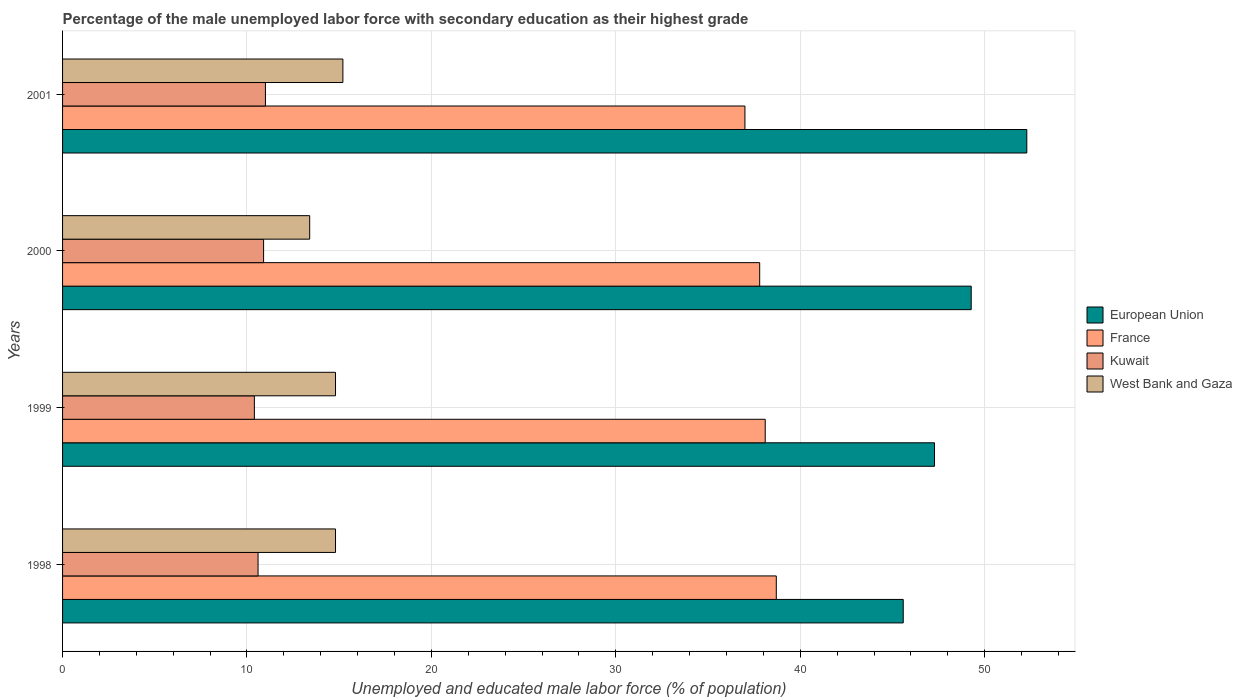How many different coloured bars are there?
Provide a succinct answer. 4. How many groups of bars are there?
Offer a terse response. 4. Are the number of bars per tick equal to the number of legend labels?
Provide a short and direct response. Yes. What is the label of the 3rd group of bars from the top?
Your answer should be very brief. 1999. What is the percentage of the unemployed male labor force with secondary education in West Bank and Gaza in 2001?
Keep it short and to the point. 15.2. Across all years, what is the maximum percentage of the unemployed male labor force with secondary education in Kuwait?
Make the answer very short. 11. Across all years, what is the minimum percentage of the unemployed male labor force with secondary education in European Union?
Provide a short and direct response. 45.58. In which year was the percentage of the unemployed male labor force with secondary education in Kuwait maximum?
Provide a succinct answer. 2001. In which year was the percentage of the unemployed male labor force with secondary education in West Bank and Gaza minimum?
Your response must be concise. 2000. What is the total percentage of the unemployed male labor force with secondary education in West Bank and Gaza in the graph?
Ensure brevity in your answer.  58.2. What is the difference between the percentage of the unemployed male labor force with secondary education in West Bank and Gaza in 2000 and that in 2001?
Keep it short and to the point. -1.8. What is the difference between the percentage of the unemployed male labor force with secondary education in West Bank and Gaza in 1998 and the percentage of the unemployed male labor force with secondary education in France in 2001?
Provide a short and direct response. -22.2. What is the average percentage of the unemployed male labor force with secondary education in France per year?
Provide a succinct answer. 37.9. In the year 1999, what is the difference between the percentage of the unemployed male labor force with secondary education in France and percentage of the unemployed male labor force with secondary education in West Bank and Gaza?
Provide a short and direct response. 23.3. In how many years, is the percentage of the unemployed male labor force with secondary education in France greater than 38 %?
Offer a terse response. 2. What is the ratio of the percentage of the unemployed male labor force with secondary education in France in 1998 to that in 1999?
Your response must be concise. 1.02. Is the percentage of the unemployed male labor force with secondary education in European Union in 1998 less than that in 2001?
Provide a short and direct response. Yes. What is the difference between the highest and the second highest percentage of the unemployed male labor force with secondary education in Kuwait?
Ensure brevity in your answer.  0.1. What is the difference between the highest and the lowest percentage of the unemployed male labor force with secondary education in West Bank and Gaza?
Your response must be concise. 1.8. What does the 2nd bar from the top in 2000 represents?
Your response must be concise. Kuwait. What does the 3rd bar from the bottom in 2000 represents?
Your answer should be compact. Kuwait. Is it the case that in every year, the sum of the percentage of the unemployed male labor force with secondary education in Kuwait and percentage of the unemployed male labor force with secondary education in European Union is greater than the percentage of the unemployed male labor force with secondary education in France?
Provide a short and direct response. Yes. Are all the bars in the graph horizontal?
Provide a short and direct response. Yes. Does the graph contain grids?
Provide a succinct answer. Yes. How many legend labels are there?
Provide a succinct answer. 4. How are the legend labels stacked?
Ensure brevity in your answer.  Vertical. What is the title of the graph?
Ensure brevity in your answer.  Percentage of the male unemployed labor force with secondary education as their highest grade. What is the label or title of the X-axis?
Offer a very short reply. Unemployed and educated male labor force (% of population). What is the Unemployed and educated male labor force (% of population) of European Union in 1998?
Give a very brief answer. 45.58. What is the Unemployed and educated male labor force (% of population) of France in 1998?
Offer a very short reply. 38.7. What is the Unemployed and educated male labor force (% of population) of Kuwait in 1998?
Your response must be concise. 10.6. What is the Unemployed and educated male labor force (% of population) of West Bank and Gaza in 1998?
Provide a succinct answer. 14.8. What is the Unemployed and educated male labor force (% of population) in European Union in 1999?
Your answer should be very brief. 47.28. What is the Unemployed and educated male labor force (% of population) of France in 1999?
Your answer should be very brief. 38.1. What is the Unemployed and educated male labor force (% of population) in Kuwait in 1999?
Provide a succinct answer. 10.4. What is the Unemployed and educated male labor force (% of population) in West Bank and Gaza in 1999?
Give a very brief answer. 14.8. What is the Unemployed and educated male labor force (% of population) of European Union in 2000?
Provide a succinct answer. 49.27. What is the Unemployed and educated male labor force (% of population) in France in 2000?
Offer a very short reply. 37.8. What is the Unemployed and educated male labor force (% of population) in Kuwait in 2000?
Offer a very short reply. 10.9. What is the Unemployed and educated male labor force (% of population) of West Bank and Gaza in 2000?
Make the answer very short. 13.4. What is the Unemployed and educated male labor force (% of population) in European Union in 2001?
Offer a very short reply. 52.28. What is the Unemployed and educated male labor force (% of population) in West Bank and Gaza in 2001?
Ensure brevity in your answer.  15.2. Across all years, what is the maximum Unemployed and educated male labor force (% of population) in European Union?
Provide a short and direct response. 52.28. Across all years, what is the maximum Unemployed and educated male labor force (% of population) of France?
Offer a terse response. 38.7. Across all years, what is the maximum Unemployed and educated male labor force (% of population) of Kuwait?
Give a very brief answer. 11. Across all years, what is the maximum Unemployed and educated male labor force (% of population) in West Bank and Gaza?
Ensure brevity in your answer.  15.2. Across all years, what is the minimum Unemployed and educated male labor force (% of population) in European Union?
Offer a very short reply. 45.58. Across all years, what is the minimum Unemployed and educated male labor force (% of population) of Kuwait?
Provide a short and direct response. 10.4. Across all years, what is the minimum Unemployed and educated male labor force (% of population) of West Bank and Gaza?
Offer a terse response. 13.4. What is the total Unemployed and educated male labor force (% of population) in European Union in the graph?
Your response must be concise. 194.41. What is the total Unemployed and educated male labor force (% of population) of France in the graph?
Offer a very short reply. 151.6. What is the total Unemployed and educated male labor force (% of population) of Kuwait in the graph?
Provide a succinct answer. 42.9. What is the total Unemployed and educated male labor force (% of population) of West Bank and Gaza in the graph?
Your answer should be very brief. 58.2. What is the difference between the Unemployed and educated male labor force (% of population) in European Union in 1998 and that in 1999?
Offer a very short reply. -1.7. What is the difference between the Unemployed and educated male labor force (% of population) in France in 1998 and that in 1999?
Make the answer very short. 0.6. What is the difference between the Unemployed and educated male labor force (% of population) in Kuwait in 1998 and that in 1999?
Provide a short and direct response. 0.2. What is the difference between the Unemployed and educated male labor force (% of population) of West Bank and Gaza in 1998 and that in 1999?
Make the answer very short. 0. What is the difference between the Unemployed and educated male labor force (% of population) in European Union in 1998 and that in 2000?
Provide a succinct answer. -3.69. What is the difference between the Unemployed and educated male labor force (% of population) of France in 1998 and that in 2000?
Keep it short and to the point. 0.9. What is the difference between the Unemployed and educated male labor force (% of population) in European Union in 1998 and that in 2001?
Keep it short and to the point. -6.7. What is the difference between the Unemployed and educated male labor force (% of population) in European Union in 1999 and that in 2000?
Offer a very short reply. -1.99. What is the difference between the Unemployed and educated male labor force (% of population) in European Union in 1999 and that in 2001?
Offer a very short reply. -5. What is the difference between the Unemployed and educated male labor force (% of population) in European Union in 2000 and that in 2001?
Offer a terse response. -3.01. What is the difference between the Unemployed and educated male labor force (% of population) in France in 2000 and that in 2001?
Make the answer very short. 0.8. What is the difference between the Unemployed and educated male labor force (% of population) of European Union in 1998 and the Unemployed and educated male labor force (% of population) of France in 1999?
Keep it short and to the point. 7.48. What is the difference between the Unemployed and educated male labor force (% of population) of European Union in 1998 and the Unemployed and educated male labor force (% of population) of Kuwait in 1999?
Ensure brevity in your answer.  35.18. What is the difference between the Unemployed and educated male labor force (% of population) of European Union in 1998 and the Unemployed and educated male labor force (% of population) of West Bank and Gaza in 1999?
Ensure brevity in your answer.  30.78. What is the difference between the Unemployed and educated male labor force (% of population) in France in 1998 and the Unemployed and educated male labor force (% of population) in Kuwait in 1999?
Your answer should be compact. 28.3. What is the difference between the Unemployed and educated male labor force (% of population) in France in 1998 and the Unemployed and educated male labor force (% of population) in West Bank and Gaza in 1999?
Ensure brevity in your answer.  23.9. What is the difference between the Unemployed and educated male labor force (% of population) of European Union in 1998 and the Unemployed and educated male labor force (% of population) of France in 2000?
Your response must be concise. 7.78. What is the difference between the Unemployed and educated male labor force (% of population) in European Union in 1998 and the Unemployed and educated male labor force (% of population) in Kuwait in 2000?
Ensure brevity in your answer.  34.68. What is the difference between the Unemployed and educated male labor force (% of population) of European Union in 1998 and the Unemployed and educated male labor force (% of population) of West Bank and Gaza in 2000?
Ensure brevity in your answer.  32.18. What is the difference between the Unemployed and educated male labor force (% of population) in France in 1998 and the Unemployed and educated male labor force (% of population) in Kuwait in 2000?
Provide a succinct answer. 27.8. What is the difference between the Unemployed and educated male labor force (% of population) of France in 1998 and the Unemployed and educated male labor force (% of population) of West Bank and Gaza in 2000?
Provide a succinct answer. 25.3. What is the difference between the Unemployed and educated male labor force (% of population) in Kuwait in 1998 and the Unemployed and educated male labor force (% of population) in West Bank and Gaza in 2000?
Offer a terse response. -2.8. What is the difference between the Unemployed and educated male labor force (% of population) in European Union in 1998 and the Unemployed and educated male labor force (% of population) in France in 2001?
Provide a short and direct response. 8.58. What is the difference between the Unemployed and educated male labor force (% of population) of European Union in 1998 and the Unemployed and educated male labor force (% of population) of Kuwait in 2001?
Provide a short and direct response. 34.58. What is the difference between the Unemployed and educated male labor force (% of population) in European Union in 1998 and the Unemployed and educated male labor force (% of population) in West Bank and Gaza in 2001?
Your answer should be very brief. 30.38. What is the difference between the Unemployed and educated male labor force (% of population) in France in 1998 and the Unemployed and educated male labor force (% of population) in Kuwait in 2001?
Make the answer very short. 27.7. What is the difference between the Unemployed and educated male labor force (% of population) in France in 1998 and the Unemployed and educated male labor force (% of population) in West Bank and Gaza in 2001?
Your answer should be compact. 23.5. What is the difference between the Unemployed and educated male labor force (% of population) in European Union in 1999 and the Unemployed and educated male labor force (% of population) in France in 2000?
Ensure brevity in your answer.  9.48. What is the difference between the Unemployed and educated male labor force (% of population) of European Union in 1999 and the Unemployed and educated male labor force (% of population) of Kuwait in 2000?
Ensure brevity in your answer.  36.38. What is the difference between the Unemployed and educated male labor force (% of population) in European Union in 1999 and the Unemployed and educated male labor force (% of population) in West Bank and Gaza in 2000?
Give a very brief answer. 33.88. What is the difference between the Unemployed and educated male labor force (% of population) of France in 1999 and the Unemployed and educated male labor force (% of population) of Kuwait in 2000?
Provide a short and direct response. 27.2. What is the difference between the Unemployed and educated male labor force (% of population) of France in 1999 and the Unemployed and educated male labor force (% of population) of West Bank and Gaza in 2000?
Give a very brief answer. 24.7. What is the difference between the Unemployed and educated male labor force (% of population) of Kuwait in 1999 and the Unemployed and educated male labor force (% of population) of West Bank and Gaza in 2000?
Make the answer very short. -3. What is the difference between the Unemployed and educated male labor force (% of population) of European Union in 1999 and the Unemployed and educated male labor force (% of population) of France in 2001?
Make the answer very short. 10.28. What is the difference between the Unemployed and educated male labor force (% of population) in European Union in 1999 and the Unemployed and educated male labor force (% of population) in Kuwait in 2001?
Provide a short and direct response. 36.28. What is the difference between the Unemployed and educated male labor force (% of population) in European Union in 1999 and the Unemployed and educated male labor force (% of population) in West Bank and Gaza in 2001?
Ensure brevity in your answer.  32.08. What is the difference between the Unemployed and educated male labor force (% of population) of France in 1999 and the Unemployed and educated male labor force (% of population) of Kuwait in 2001?
Offer a very short reply. 27.1. What is the difference between the Unemployed and educated male labor force (% of population) of France in 1999 and the Unemployed and educated male labor force (% of population) of West Bank and Gaza in 2001?
Keep it short and to the point. 22.9. What is the difference between the Unemployed and educated male labor force (% of population) of European Union in 2000 and the Unemployed and educated male labor force (% of population) of France in 2001?
Provide a short and direct response. 12.27. What is the difference between the Unemployed and educated male labor force (% of population) of European Union in 2000 and the Unemployed and educated male labor force (% of population) of Kuwait in 2001?
Your answer should be compact. 38.27. What is the difference between the Unemployed and educated male labor force (% of population) in European Union in 2000 and the Unemployed and educated male labor force (% of population) in West Bank and Gaza in 2001?
Keep it short and to the point. 34.07. What is the difference between the Unemployed and educated male labor force (% of population) in France in 2000 and the Unemployed and educated male labor force (% of population) in Kuwait in 2001?
Your answer should be very brief. 26.8. What is the difference between the Unemployed and educated male labor force (% of population) in France in 2000 and the Unemployed and educated male labor force (% of population) in West Bank and Gaza in 2001?
Provide a succinct answer. 22.6. What is the difference between the Unemployed and educated male labor force (% of population) in Kuwait in 2000 and the Unemployed and educated male labor force (% of population) in West Bank and Gaza in 2001?
Make the answer very short. -4.3. What is the average Unemployed and educated male labor force (% of population) in European Union per year?
Offer a terse response. 48.6. What is the average Unemployed and educated male labor force (% of population) in France per year?
Provide a short and direct response. 37.9. What is the average Unemployed and educated male labor force (% of population) of Kuwait per year?
Your response must be concise. 10.72. What is the average Unemployed and educated male labor force (% of population) of West Bank and Gaza per year?
Offer a very short reply. 14.55. In the year 1998, what is the difference between the Unemployed and educated male labor force (% of population) of European Union and Unemployed and educated male labor force (% of population) of France?
Offer a very short reply. 6.88. In the year 1998, what is the difference between the Unemployed and educated male labor force (% of population) of European Union and Unemployed and educated male labor force (% of population) of Kuwait?
Ensure brevity in your answer.  34.98. In the year 1998, what is the difference between the Unemployed and educated male labor force (% of population) of European Union and Unemployed and educated male labor force (% of population) of West Bank and Gaza?
Your answer should be very brief. 30.78. In the year 1998, what is the difference between the Unemployed and educated male labor force (% of population) of France and Unemployed and educated male labor force (% of population) of Kuwait?
Keep it short and to the point. 28.1. In the year 1998, what is the difference between the Unemployed and educated male labor force (% of population) in France and Unemployed and educated male labor force (% of population) in West Bank and Gaza?
Provide a short and direct response. 23.9. In the year 1999, what is the difference between the Unemployed and educated male labor force (% of population) of European Union and Unemployed and educated male labor force (% of population) of France?
Provide a succinct answer. 9.18. In the year 1999, what is the difference between the Unemployed and educated male labor force (% of population) in European Union and Unemployed and educated male labor force (% of population) in Kuwait?
Give a very brief answer. 36.88. In the year 1999, what is the difference between the Unemployed and educated male labor force (% of population) of European Union and Unemployed and educated male labor force (% of population) of West Bank and Gaza?
Keep it short and to the point. 32.48. In the year 1999, what is the difference between the Unemployed and educated male labor force (% of population) in France and Unemployed and educated male labor force (% of population) in Kuwait?
Offer a terse response. 27.7. In the year 1999, what is the difference between the Unemployed and educated male labor force (% of population) of France and Unemployed and educated male labor force (% of population) of West Bank and Gaza?
Your answer should be compact. 23.3. In the year 1999, what is the difference between the Unemployed and educated male labor force (% of population) of Kuwait and Unemployed and educated male labor force (% of population) of West Bank and Gaza?
Give a very brief answer. -4.4. In the year 2000, what is the difference between the Unemployed and educated male labor force (% of population) of European Union and Unemployed and educated male labor force (% of population) of France?
Keep it short and to the point. 11.47. In the year 2000, what is the difference between the Unemployed and educated male labor force (% of population) in European Union and Unemployed and educated male labor force (% of population) in Kuwait?
Keep it short and to the point. 38.37. In the year 2000, what is the difference between the Unemployed and educated male labor force (% of population) of European Union and Unemployed and educated male labor force (% of population) of West Bank and Gaza?
Your answer should be compact. 35.87. In the year 2000, what is the difference between the Unemployed and educated male labor force (% of population) in France and Unemployed and educated male labor force (% of population) in Kuwait?
Your answer should be very brief. 26.9. In the year 2000, what is the difference between the Unemployed and educated male labor force (% of population) of France and Unemployed and educated male labor force (% of population) of West Bank and Gaza?
Keep it short and to the point. 24.4. In the year 2000, what is the difference between the Unemployed and educated male labor force (% of population) of Kuwait and Unemployed and educated male labor force (% of population) of West Bank and Gaza?
Make the answer very short. -2.5. In the year 2001, what is the difference between the Unemployed and educated male labor force (% of population) of European Union and Unemployed and educated male labor force (% of population) of France?
Provide a succinct answer. 15.28. In the year 2001, what is the difference between the Unemployed and educated male labor force (% of population) in European Union and Unemployed and educated male labor force (% of population) in Kuwait?
Keep it short and to the point. 41.28. In the year 2001, what is the difference between the Unemployed and educated male labor force (% of population) of European Union and Unemployed and educated male labor force (% of population) of West Bank and Gaza?
Offer a very short reply. 37.08. In the year 2001, what is the difference between the Unemployed and educated male labor force (% of population) in France and Unemployed and educated male labor force (% of population) in West Bank and Gaza?
Offer a very short reply. 21.8. What is the ratio of the Unemployed and educated male labor force (% of population) in European Union in 1998 to that in 1999?
Keep it short and to the point. 0.96. What is the ratio of the Unemployed and educated male labor force (% of population) in France in 1998 to that in 1999?
Provide a short and direct response. 1.02. What is the ratio of the Unemployed and educated male labor force (% of population) of Kuwait in 1998 to that in 1999?
Ensure brevity in your answer.  1.02. What is the ratio of the Unemployed and educated male labor force (% of population) of West Bank and Gaza in 1998 to that in 1999?
Your answer should be compact. 1. What is the ratio of the Unemployed and educated male labor force (% of population) of European Union in 1998 to that in 2000?
Give a very brief answer. 0.93. What is the ratio of the Unemployed and educated male labor force (% of population) of France in 1998 to that in 2000?
Your answer should be very brief. 1.02. What is the ratio of the Unemployed and educated male labor force (% of population) of Kuwait in 1998 to that in 2000?
Offer a very short reply. 0.97. What is the ratio of the Unemployed and educated male labor force (% of population) of West Bank and Gaza in 1998 to that in 2000?
Make the answer very short. 1.1. What is the ratio of the Unemployed and educated male labor force (% of population) in European Union in 1998 to that in 2001?
Your answer should be very brief. 0.87. What is the ratio of the Unemployed and educated male labor force (% of population) in France in 1998 to that in 2001?
Your answer should be very brief. 1.05. What is the ratio of the Unemployed and educated male labor force (% of population) of Kuwait in 1998 to that in 2001?
Offer a terse response. 0.96. What is the ratio of the Unemployed and educated male labor force (% of population) of West Bank and Gaza in 1998 to that in 2001?
Your response must be concise. 0.97. What is the ratio of the Unemployed and educated male labor force (% of population) in European Union in 1999 to that in 2000?
Your answer should be compact. 0.96. What is the ratio of the Unemployed and educated male labor force (% of population) in France in 1999 to that in 2000?
Give a very brief answer. 1.01. What is the ratio of the Unemployed and educated male labor force (% of population) of Kuwait in 1999 to that in 2000?
Your answer should be compact. 0.95. What is the ratio of the Unemployed and educated male labor force (% of population) in West Bank and Gaza in 1999 to that in 2000?
Provide a short and direct response. 1.1. What is the ratio of the Unemployed and educated male labor force (% of population) of European Union in 1999 to that in 2001?
Offer a very short reply. 0.9. What is the ratio of the Unemployed and educated male labor force (% of population) in France in 1999 to that in 2001?
Your answer should be compact. 1.03. What is the ratio of the Unemployed and educated male labor force (% of population) of Kuwait in 1999 to that in 2001?
Provide a succinct answer. 0.95. What is the ratio of the Unemployed and educated male labor force (% of population) of West Bank and Gaza in 1999 to that in 2001?
Provide a short and direct response. 0.97. What is the ratio of the Unemployed and educated male labor force (% of population) in European Union in 2000 to that in 2001?
Keep it short and to the point. 0.94. What is the ratio of the Unemployed and educated male labor force (% of population) in France in 2000 to that in 2001?
Ensure brevity in your answer.  1.02. What is the ratio of the Unemployed and educated male labor force (% of population) in Kuwait in 2000 to that in 2001?
Provide a succinct answer. 0.99. What is the ratio of the Unemployed and educated male labor force (% of population) in West Bank and Gaza in 2000 to that in 2001?
Offer a very short reply. 0.88. What is the difference between the highest and the second highest Unemployed and educated male labor force (% of population) in European Union?
Your response must be concise. 3.01. What is the difference between the highest and the second highest Unemployed and educated male labor force (% of population) of West Bank and Gaza?
Give a very brief answer. 0.4. What is the difference between the highest and the lowest Unemployed and educated male labor force (% of population) in European Union?
Your response must be concise. 6.7. 